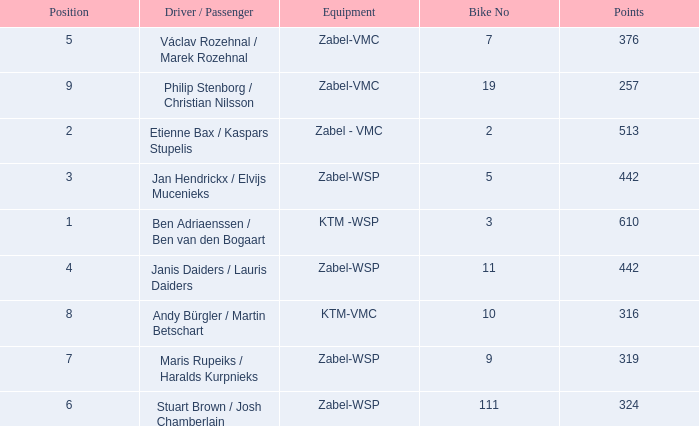What are the points for ktm-vmc equipment?  316.0. 